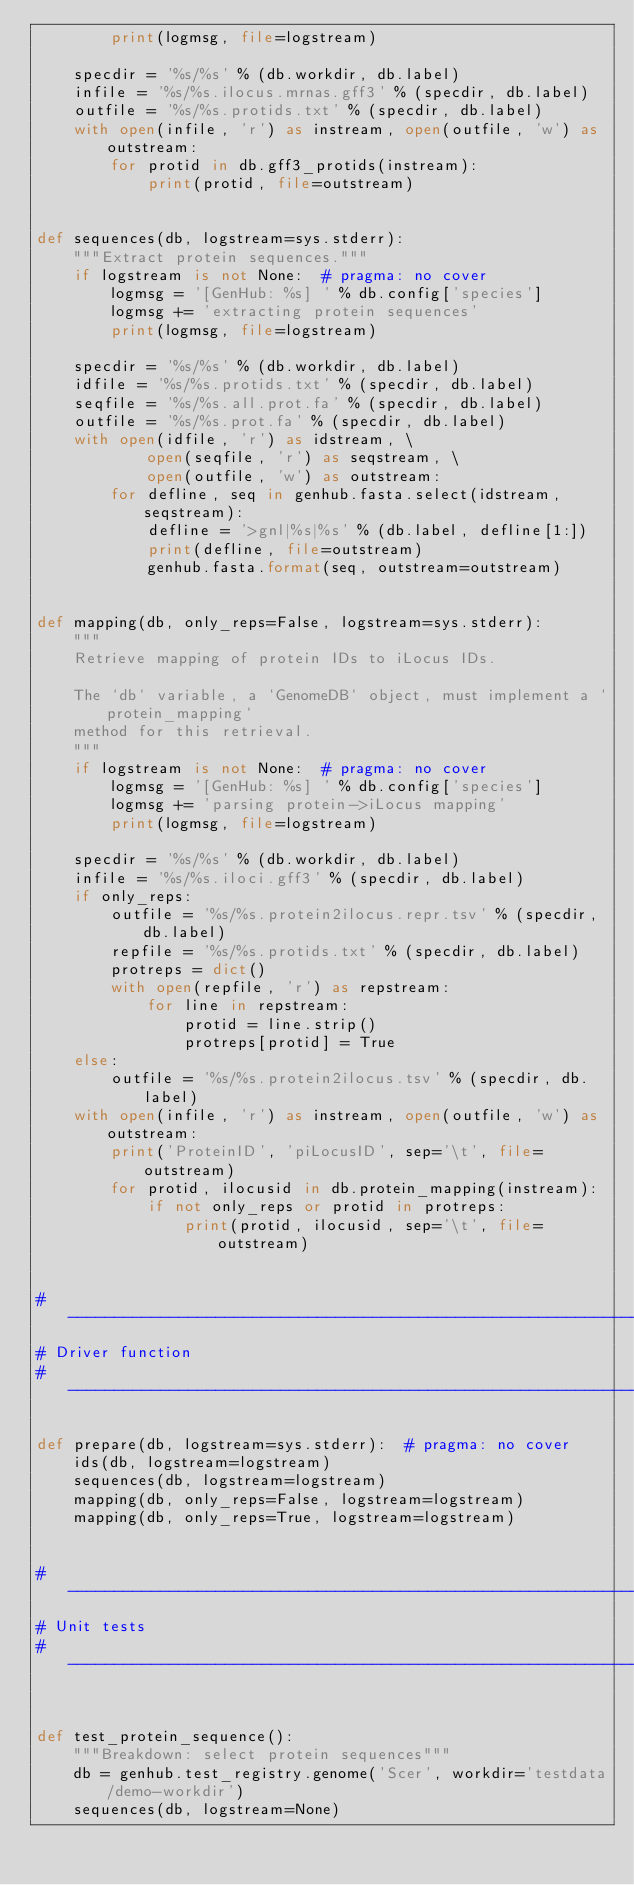<code> <loc_0><loc_0><loc_500><loc_500><_Python_>        print(logmsg, file=logstream)

    specdir = '%s/%s' % (db.workdir, db.label)
    infile = '%s/%s.ilocus.mrnas.gff3' % (specdir, db.label)
    outfile = '%s/%s.protids.txt' % (specdir, db.label)
    with open(infile, 'r') as instream, open(outfile, 'w') as outstream:
        for protid in db.gff3_protids(instream):
            print(protid, file=outstream)


def sequences(db, logstream=sys.stderr):
    """Extract protein sequences."""
    if logstream is not None:  # pragma: no cover
        logmsg = '[GenHub: %s] ' % db.config['species']
        logmsg += 'extracting protein sequences'
        print(logmsg, file=logstream)

    specdir = '%s/%s' % (db.workdir, db.label)
    idfile = '%s/%s.protids.txt' % (specdir, db.label)
    seqfile = '%s/%s.all.prot.fa' % (specdir, db.label)
    outfile = '%s/%s.prot.fa' % (specdir, db.label)
    with open(idfile, 'r') as idstream, \
            open(seqfile, 'r') as seqstream, \
            open(outfile, 'w') as outstream:
        for defline, seq in genhub.fasta.select(idstream, seqstream):
            defline = '>gnl|%s|%s' % (db.label, defline[1:])
            print(defline, file=outstream)
            genhub.fasta.format(seq, outstream=outstream)


def mapping(db, only_reps=False, logstream=sys.stderr):
    """
    Retrieve mapping of protein IDs to iLocus IDs.

    The `db` variable, a `GenomeDB` object, must implement a `protein_mapping`
    method for this retrieval.
    """
    if logstream is not None:  # pragma: no cover
        logmsg = '[GenHub: %s] ' % db.config['species']
        logmsg += 'parsing protein->iLocus mapping'
        print(logmsg, file=logstream)

    specdir = '%s/%s' % (db.workdir, db.label)
    infile = '%s/%s.iloci.gff3' % (specdir, db.label)
    if only_reps:
        outfile = '%s/%s.protein2ilocus.repr.tsv' % (specdir, db.label)
        repfile = '%s/%s.protids.txt' % (specdir, db.label)
        protreps = dict()
        with open(repfile, 'r') as repstream:
            for line in repstream:
                protid = line.strip()
                protreps[protid] = True
    else:
        outfile = '%s/%s.protein2ilocus.tsv' % (specdir, db.label)
    with open(infile, 'r') as instream, open(outfile, 'w') as outstream:
        print('ProteinID', 'piLocusID', sep='\t', file=outstream)
        for protid, ilocusid in db.protein_mapping(instream):
            if not only_reps or protid in protreps:
                print(protid, ilocusid, sep='\t', file=outstream)


# -----------------------------------------------------------------------------
# Driver function
# -----------------------------------------------------------------------------

def prepare(db, logstream=sys.stderr):  # pragma: no cover
    ids(db, logstream=logstream)
    sequences(db, logstream=logstream)
    mapping(db, only_reps=False, logstream=logstream)
    mapping(db, only_reps=True, logstream=logstream)


# -----------------------------------------------------------------------------
# Unit tests
# -----------------------------------------------------------------------------


def test_protein_sequence():
    """Breakdown: select protein sequences"""
    db = genhub.test_registry.genome('Scer', workdir='testdata/demo-workdir')
    sequences(db, logstream=None)</code> 